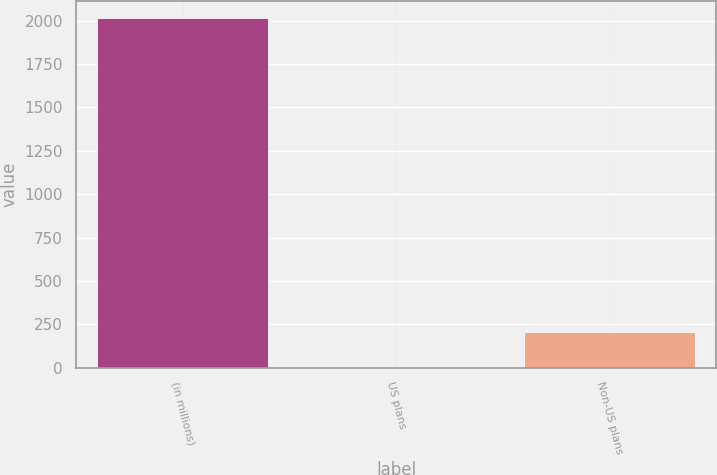Convert chart to OTSL. <chart><loc_0><loc_0><loc_500><loc_500><bar_chart><fcel>(in millions)<fcel>US plans<fcel>Non-US plans<nl><fcel>2013<fcel>6<fcel>206.7<nl></chart> 